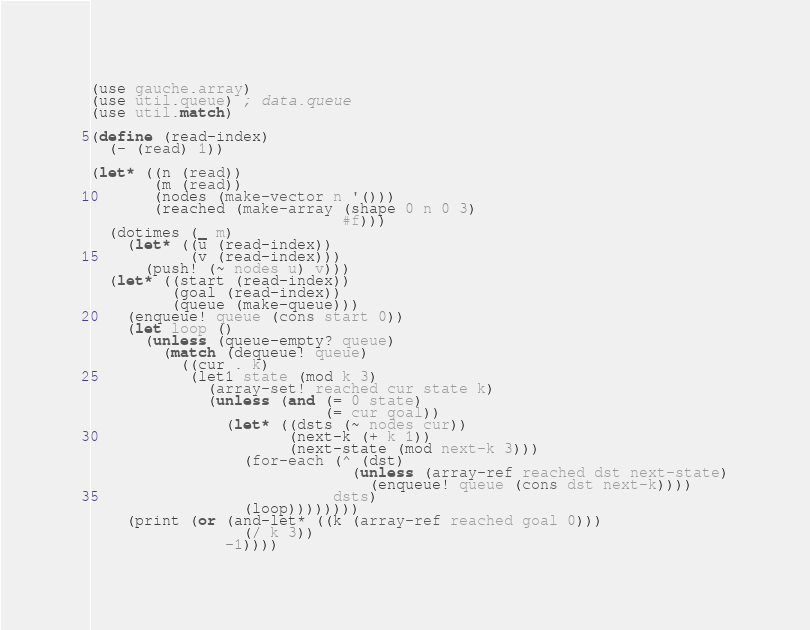Convert code to text. <code><loc_0><loc_0><loc_500><loc_500><_Scheme_>(use gauche.array)
(use util.queue) ; data.queue
(use util.match)

(define (read-index)
  (- (read) 1))

(let* ((n (read))
       (m (read))
       (nodes (make-vector n '()))
       (reached (make-array (shape 0 n 0 3)
                            #f)))
  (dotimes (_ m)
    (let* ((u (read-index))
           (v (read-index)))
      (push! (~ nodes u) v)))
  (let* ((start (read-index))
         (goal (read-index))
         (queue (make-queue)))
    (enqueue! queue (cons start 0))
    (let loop ()
      (unless (queue-empty? queue)
        (match (dequeue! queue)
          ((cur . k)
           (let1 state (mod k 3)
             (array-set! reached cur state k)
             (unless (and (= 0 state)
                          (= cur goal))
               (let* ((dsts (~ nodes cur))
                      (next-k (+ k 1))
                      (next-state (mod next-k 3)))
                 (for-each (^ (dst)
                             (unless (array-ref reached dst next-state)
                               (enqueue! queue (cons dst next-k))))
                           dsts)
                 (loop))))))))
    (print (or (and-let* ((k (array-ref reached goal 0)))
                 (/ k 3))
               -1))))
</code> 